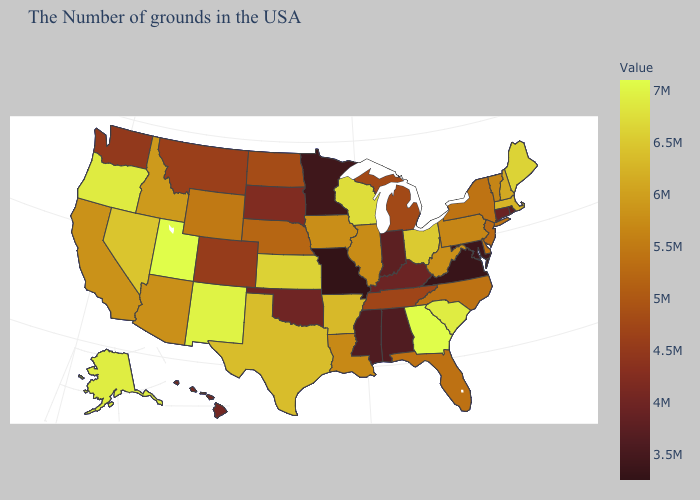Among the states that border South Carolina , which have the highest value?
Answer briefly. Georgia. Does Virginia have the lowest value in the South?
Give a very brief answer. Yes. Does Georgia have the highest value in the USA?
Give a very brief answer. Yes. Does Illinois have a lower value than Ohio?
Keep it brief. Yes. Among the states that border Texas , which have the highest value?
Give a very brief answer. New Mexico. Which states hav the highest value in the MidWest?
Answer briefly. Wisconsin. Which states have the lowest value in the Northeast?
Keep it brief. Rhode Island. 